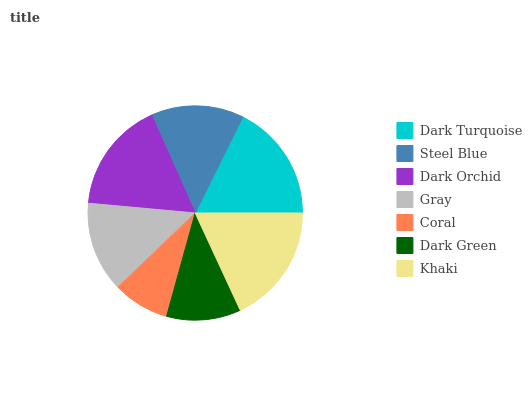Is Coral the minimum?
Answer yes or no. Yes. Is Khaki the maximum?
Answer yes or no. Yes. Is Steel Blue the minimum?
Answer yes or no. No. Is Steel Blue the maximum?
Answer yes or no. No. Is Dark Turquoise greater than Steel Blue?
Answer yes or no. Yes. Is Steel Blue less than Dark Turquoise?
Answer yes or no. Yes. Is Steel Blue greater than Dark Turquoise?
Answer yes or no. No. Is Dark Turquoise less than Steel Blue?
Answer yes or no. No. Is Steel Blue the high median?
Answer yes or no. Yes. Is Steel Blue the low median?
Answer yes or no. Yes. Is Dark Turquoise the high median?
Answer yes or no. No. Is Coral the low median?
Answer yes or no. No. 